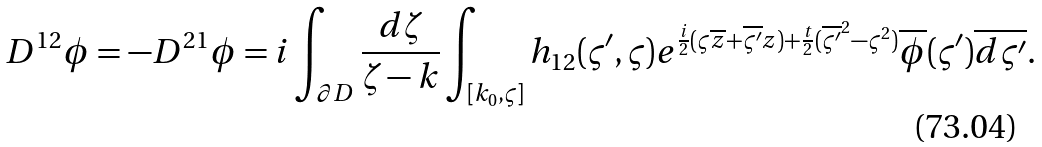Convert formula to latex. <formula><loc_0><loc_0><loc_500><loc_500>D ^ { 1 2 } \phi = - D ^ { 2 1 } \phi = i \int _ { \partial D } \frac { d \zeta } { \zeta - k } \int _ { [ k _ { 0 } , \varsigma ] } { h _ { 1 2 } ( \varsigma ^ { \prime } , \varsigma ) } e ^ { { \frac { i } { 2 } } ( \varsigma \overline { z } + \overline { \varsigma ^ { \prime } } z ) + \frac { t } { 2 } ( \overline { \varsigma ^ { \prime } } ^ { 2 } - \varsigma ^ { 2 } ) } \overline { \phi } ( \varsigma ^ { \prime } ) \overline { d \varsigma ^ { \prime } } .</formula> 